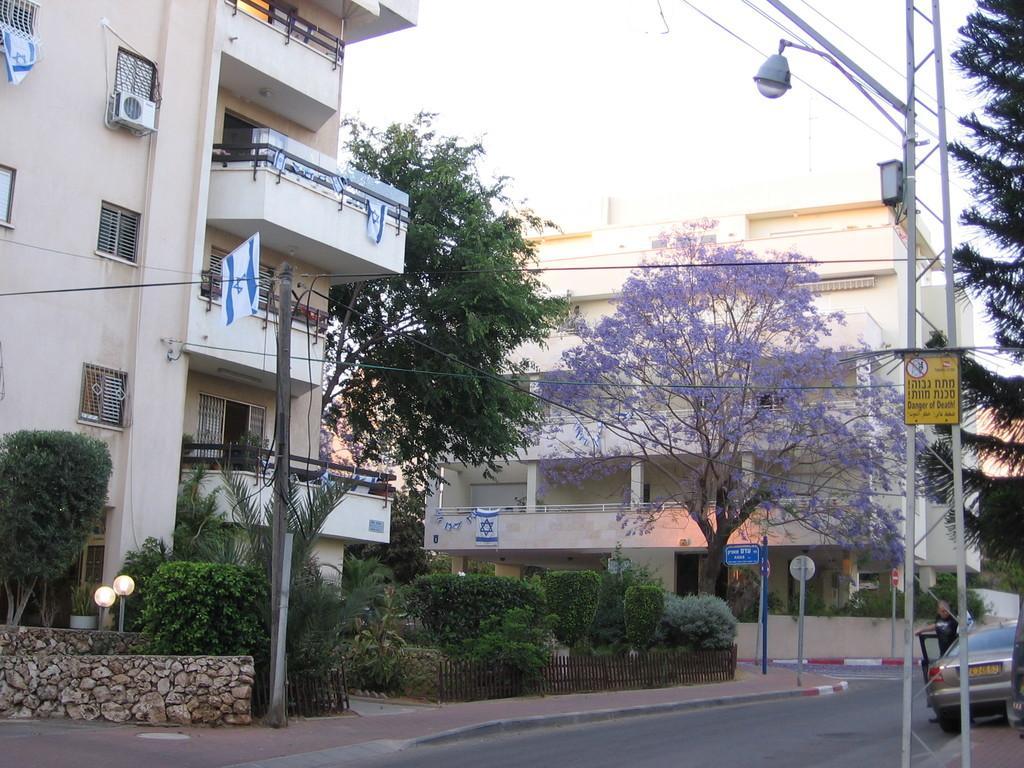Please provide a concise description of this image. In the image we can see some poles and plants and trees and sign boards. Behind them there are some buildings and there are some vehicles. Behind the vehicle a man is standing. 